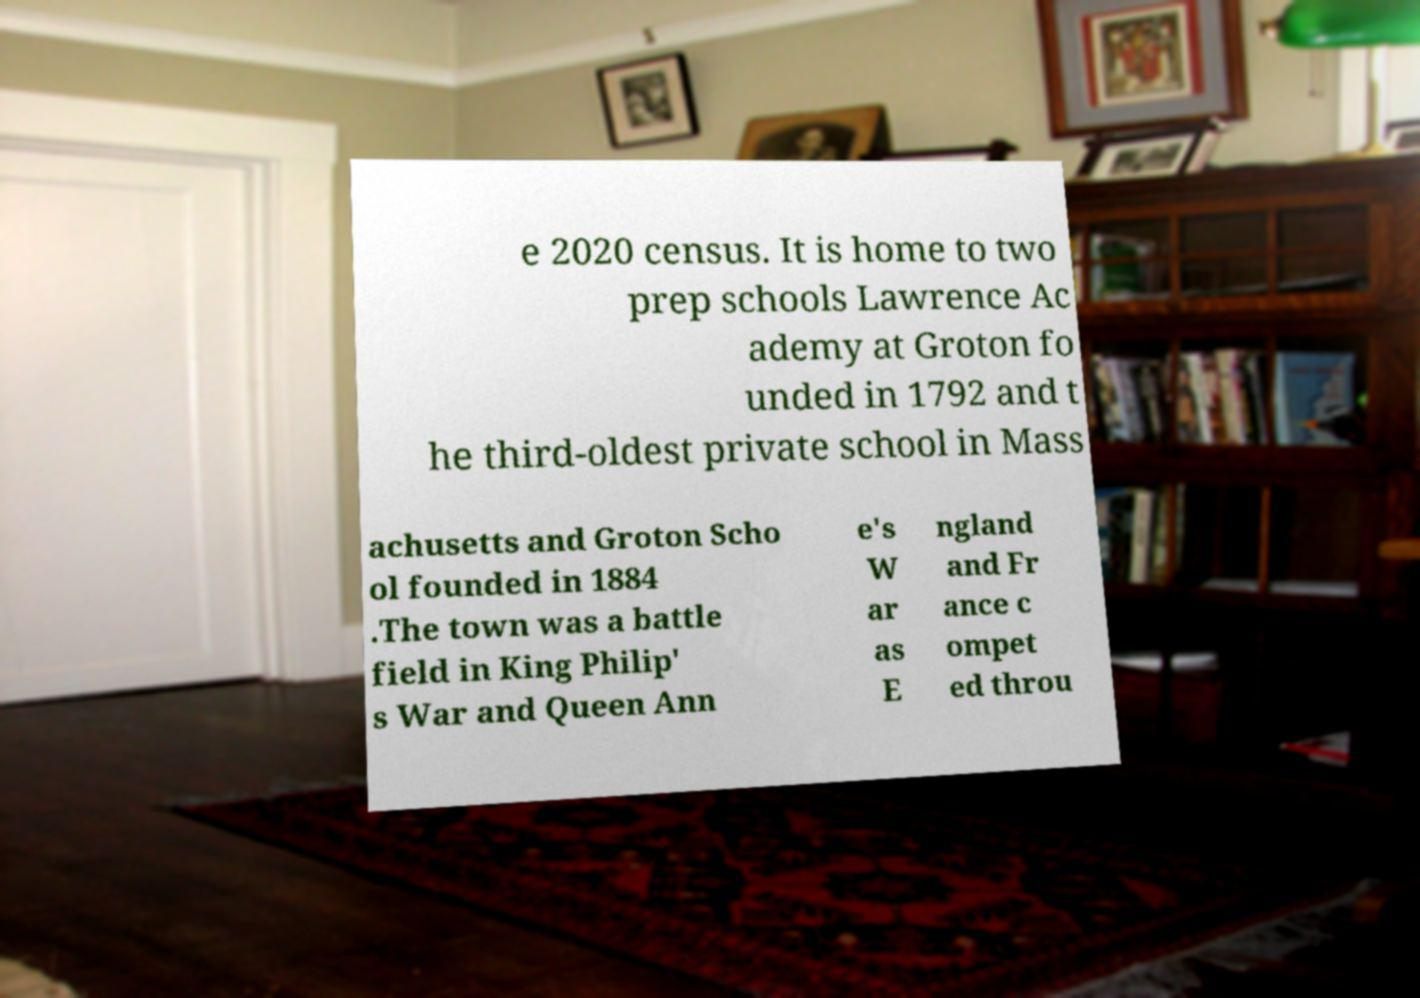Can you accurately transcribe the text from the provided image for me? e 2020 census. It is home to two prep schools Lawrence Ac ademy at Groton fo unded in 1792 and t he third-oldest private school in Mass achusetts and Groton Scho ol founded in 1884 .The town was a battle field in King Philip' s War and Queen Ann e's W ar as E ngland and Fr ance c ompet ed throu 